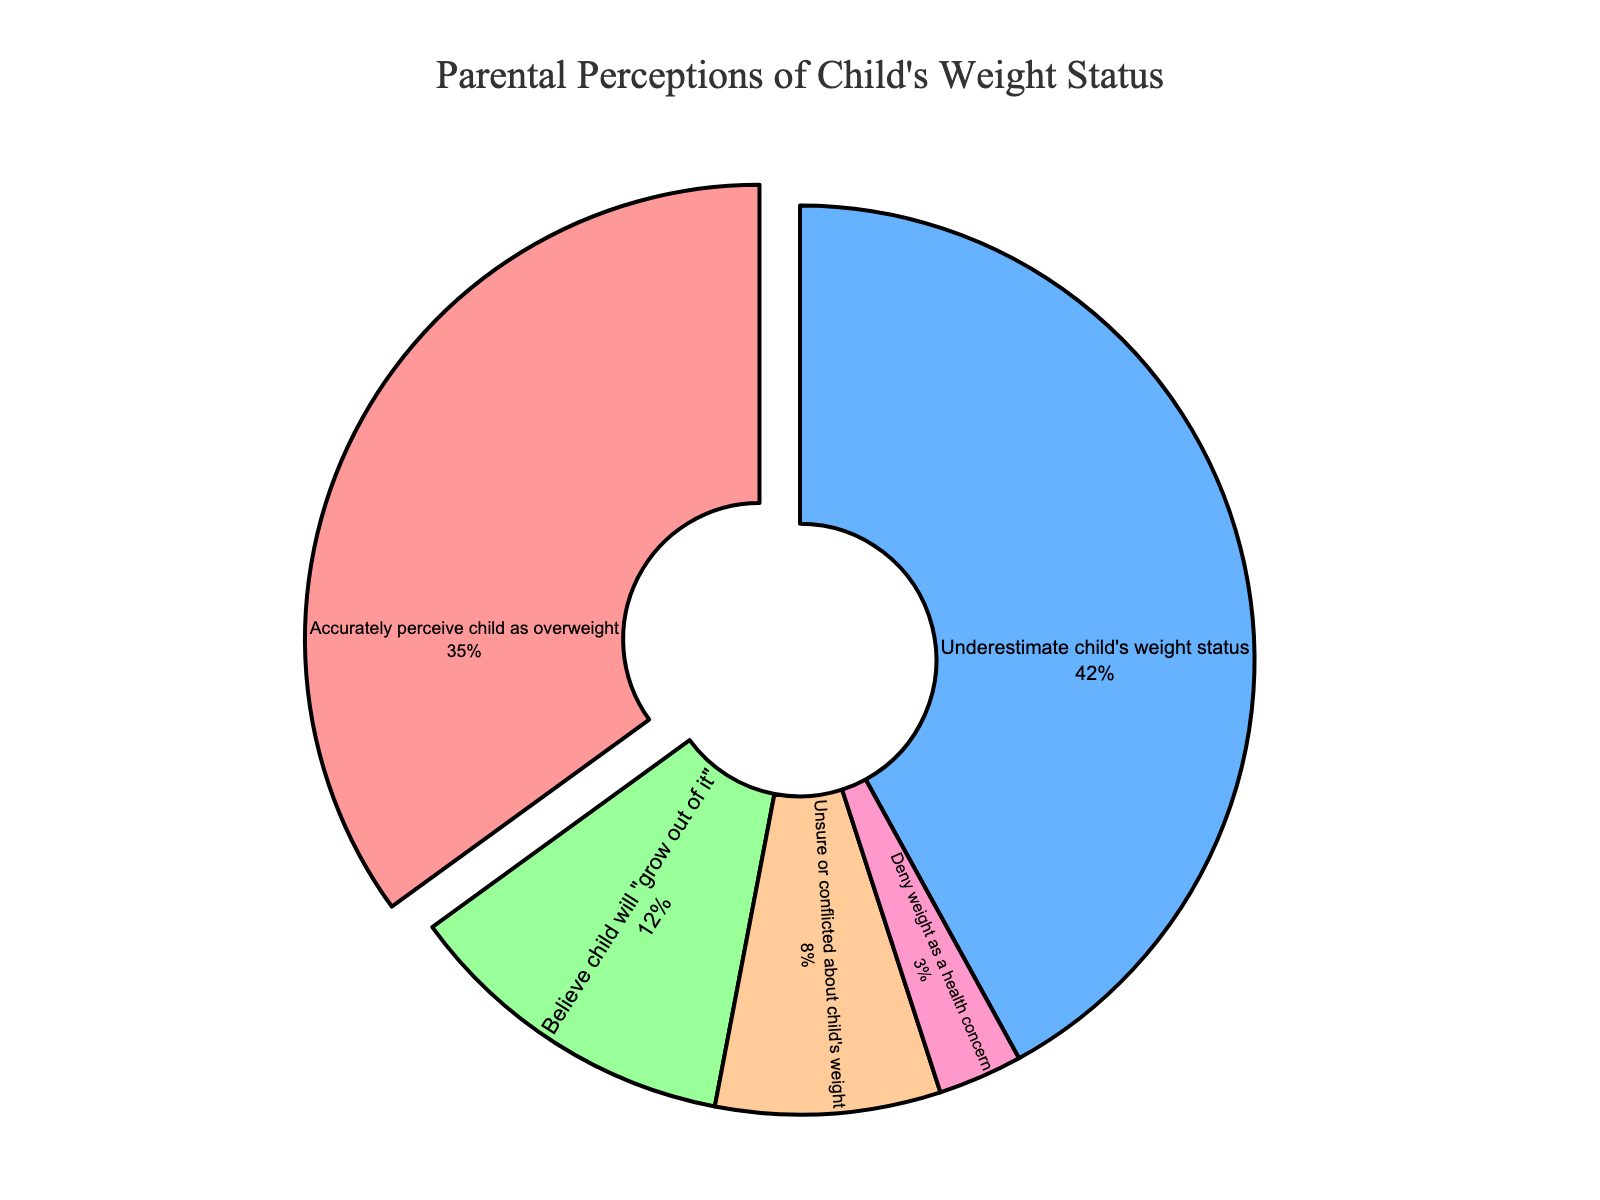What percentage of parents underestimate their child's weight status? By looking at the figure, we find the section labeled "Underestimate child's weight status," which shows the corresponding percentage.
Answer: 42% Compare the percentage of parents accurately perceiving their child as overweight to the percentage of parents believing their child will "grow out of it." Which is higher, and by how much? The figure shows the percentages of parents accurately perceiving their child as overweight as 35% and those believing their child will "grow out of it" as 12%. Subtract 12% from 35% to find the difference.
Answer: 35% is higher by 23% What's the combined percentage of parents who are either unsure or conflicted and those who deny weight as a health concern? The figure provides percentages for both categories: 8% for unsure or conflicted and 3% for denying weight as a health concern. Adding these together gives the combined percentage.
Answer: 11% Which category is represented by the pink color in the figure? The color pink is used to represent the section labeled "Unsure or conflicted about child's weight."
Answer: Unsure or conflicted about child's weight Out of the given categories, what proportion of parents either underestimate their child's weight status or believe their child will "grow out of it"? The figure shows that 42% of parents underestimate their child's weight status and 12% believe their child will "grow out of it." Adding these percentages gives their combined proportion.
Answer: 54% Which category has the smallest percentage, and what is that percentage? By examining the figure, the smallest percentage corresponds to the category "Deny weight as a health concern."
Answer: 3% What portion of parents do not accurately perceive their child's weight status (including underestimating, believing the child will grow out of it, unsure or conflicted, and denying weight as a health concern)? The figure provides percentages for these categories as 42%, 12%, 8%, and 3%. Adding them together provides the total proportion of parents who do not accurately perceive their child's weight status.
Answer: 65% How does the percentage of parents who accurately perceive their child as overweight compare to those who are unsure or conflicted and those who deny weight as a health concern combined? The figure shows 35% of parents accurately perceive their child as overweight, while 8% are unsure or conflicted and 3% deny weight as a health concern. Adding 8% and 3% gives a combined 11%. Comparing 35% to 11% shows 35% is higher.
Answer: 35% is higher than 11% What are the top two parental perceptions in terms of percentage? By examining the figure, the top two categories are "Underestimate child's weight status" with 42% and "Accurately perceive child as overweight" with 35%.
Answer: Underestimate child's weight status and Accurately perceive child as overweight 